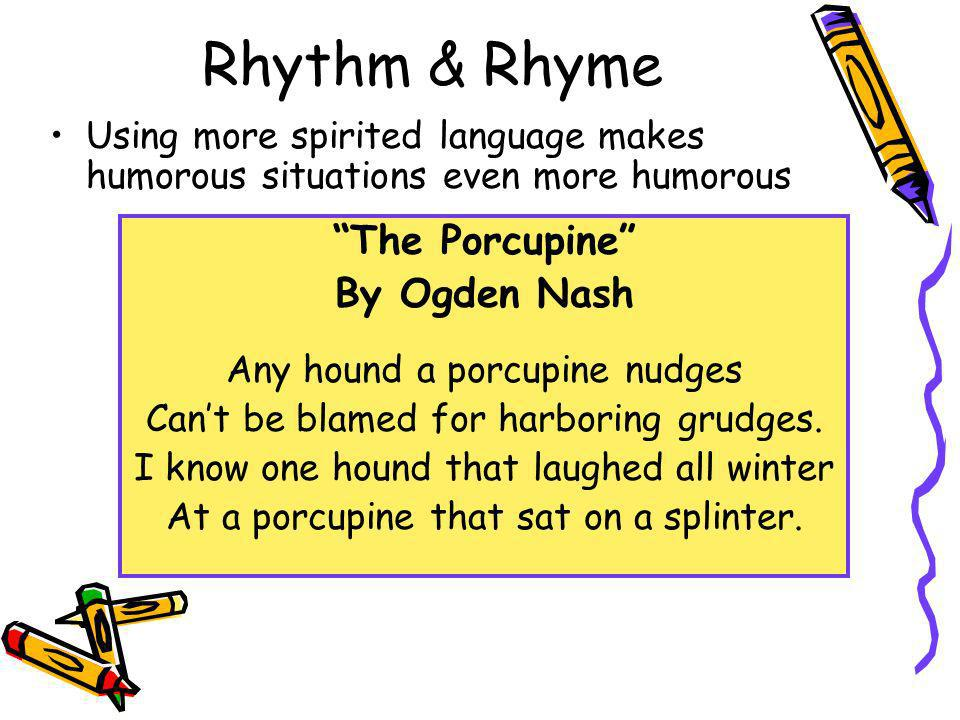What poetic technique does Ogden Nash utilize in the featured poem to create humor? Ogden Nash employs rhyme and a light-hearted narrative to create humor in the poem. The rhyme is evident in the words "nudges" and "grudges," as well as "winter" and "splinter." This rhyme scheme, combined with the amusing mental image of a hound interacting with a porcupine and the comical scenario of a porcupine sitting on a splinter, contributes to the humorous tone of the poem. The humor is further amplified by the playful language and the unexpected twist at the end, where instead of the hound being in discomfort from the porcupine's quills, it is the porcupine that ends up sitting on a splinter. 